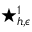Convert formula to latex. <formula><loc_0><loc_0><loc_500><loc_500>^ { * } _ { h , \epsilon } ^ { 1 }</formula> 